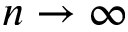Convert formula to latex. <formula><loc_0><loc_0><loc_500><loc_500>n \rightarrow \infty</formula> 